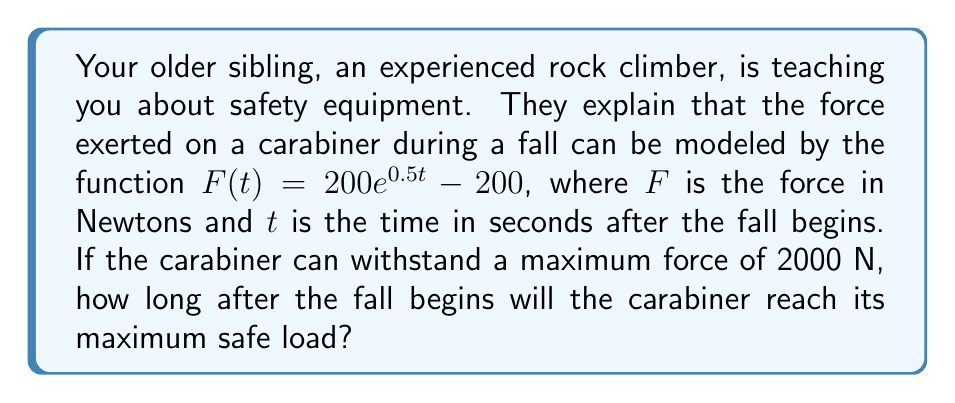What is the answer to this math problem? Let's approach this step-by-step:

1) We're given the function $F(t) = 200e^{0.5t} - 200$, where $F$ is the force in Newtons and $t$ is the time in seconds.

2) We need to find $t$ when $F(t) = 2000$ N (the maximum safe load).

3) Let's set up the equation:
   $2000 = 200e^{0.5t} - 200$

4) Add 200 to both sides:
   $2200 = 200e^{0.5t}$

5) Divide both sides by 200:
   $11 = e^{0.5t}$

6) Take the natural log of both sides:
   $\ln(11) = \ln(e^{0.5t})$

7) Simplify the right side using the properties of logarithms:
   $\ln(11) = 0.5t$

8) Multiply both sides by 2:
   $2\ln(11) = t$

9) Calculate the value (rounded to two decimal places):
   $t \approx 4.79$ seconds

Therefore, the carabiner will reach its maximum safe load approximately 4.79 seconds after the fall begins.
Answer: $4.79$ seconds 